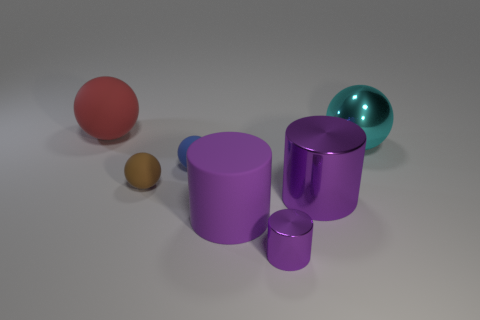How many purple cylinders must be subtracted to get 1 purple cylinders? 2 Subtract all tiny shiny cylinders. How many cylinders are left? 2 Subtract all blue balls. How many balls are left? 3 Subtract 1 cylinders. How many cylinders are left? 2 Add 1 metallic objects. How many objects exist? 8 Subtract all brown cylinders. Subtract all blue blocks. How many cylinders are left? 3 Subtract all cylinders. How many objects are left? 4 Subtract 0 purple blocks. How many objects are left? 7 Subtract all big purple matte cylinders. Subtract all tiny blue balls. How many objects are left? 5 Add 5 purple cylinders. How many purple cylinders are left? 8 